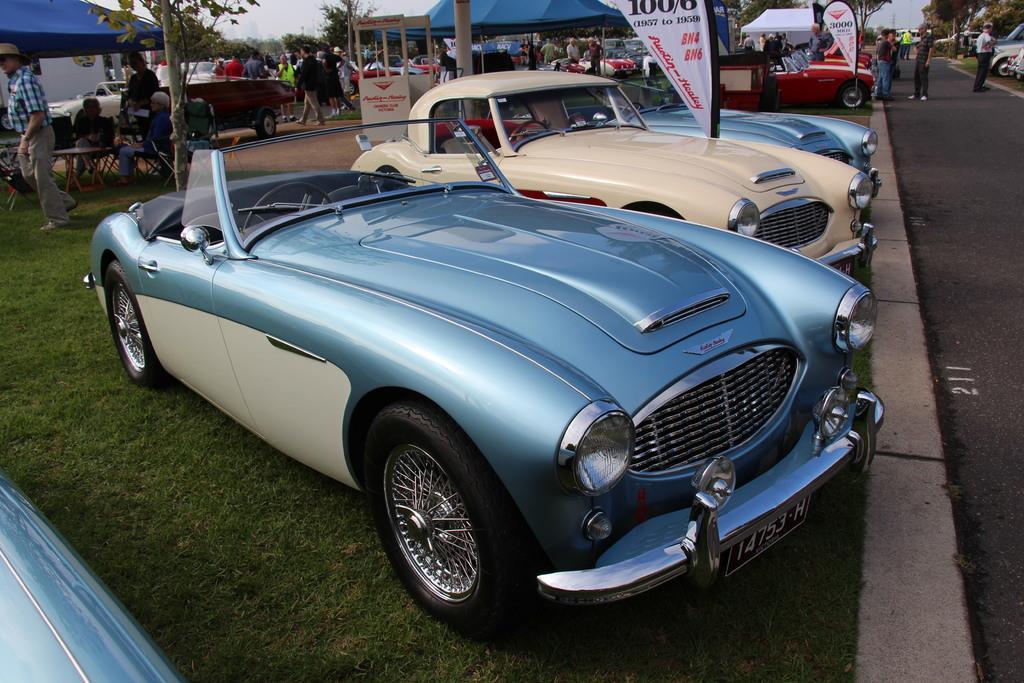In one or two sentences, can you explain what this image depicts? In this image in the center there are cars, and at the bottom there is grass and walkway. And in the background there are some tents, tables, chairs and some people are sitting and some of them are walking and also there are some boards and trees. 